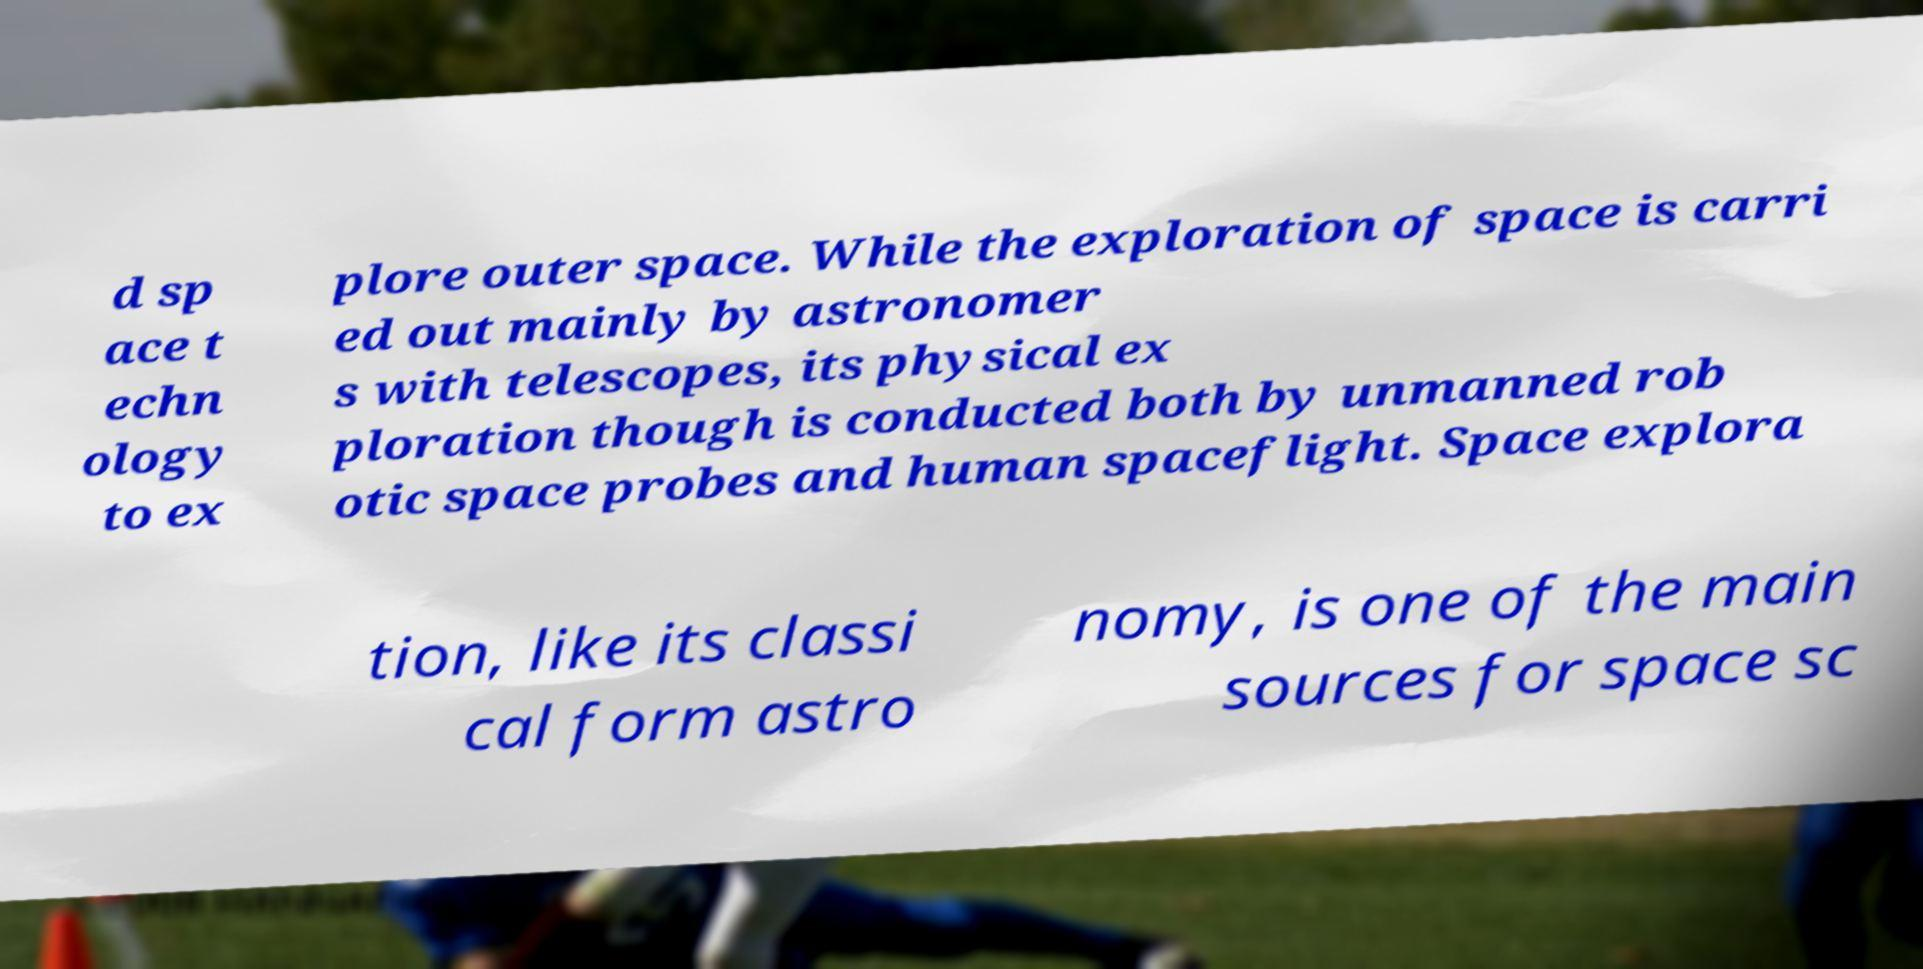Could you extract and type out the text from this image? d sp ace t echn ology to ex plore outer space. While the exploration of space is carri ed out mainly by astronomer s with telescopes, its physical ex ploration though is conducted both by unmanned rob otic space probes and human spaceflight. Space explora tion, like its classi cal form astro nomy, is one of the main sources for space sc 